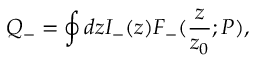<formula> <loc_0><loc_0><loc_500><loc_500>Q _ { - } = \oint d z I _ { - } ( z ) F _ { - } ( { \frac { z } { z _ { 0 } } } ; P ) ,</formula> 